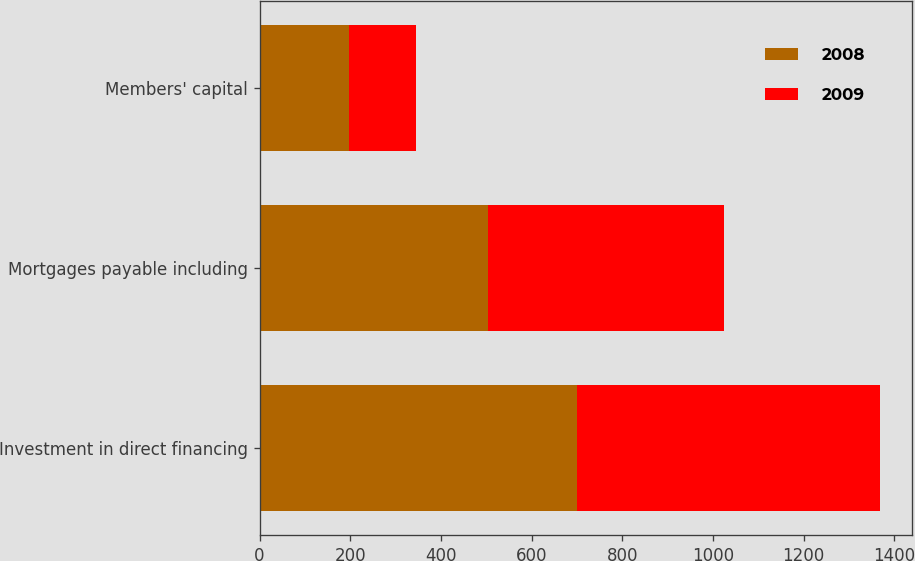Convert chart to OTSL. <chart><loc_0><loc_0><loc_500><loc_500><stacked_bar_chart><ecel><fcel>Investment in direct financing<fcel>Mortgages payable including<fcel>Members' capital<nl><fcel>2008<fcel>701.1<fcel>503.5<fcel>197.6<nl><fcel>2009<fcel>668.6<fcel>521.4<fcel>147.2<nl></chart> 